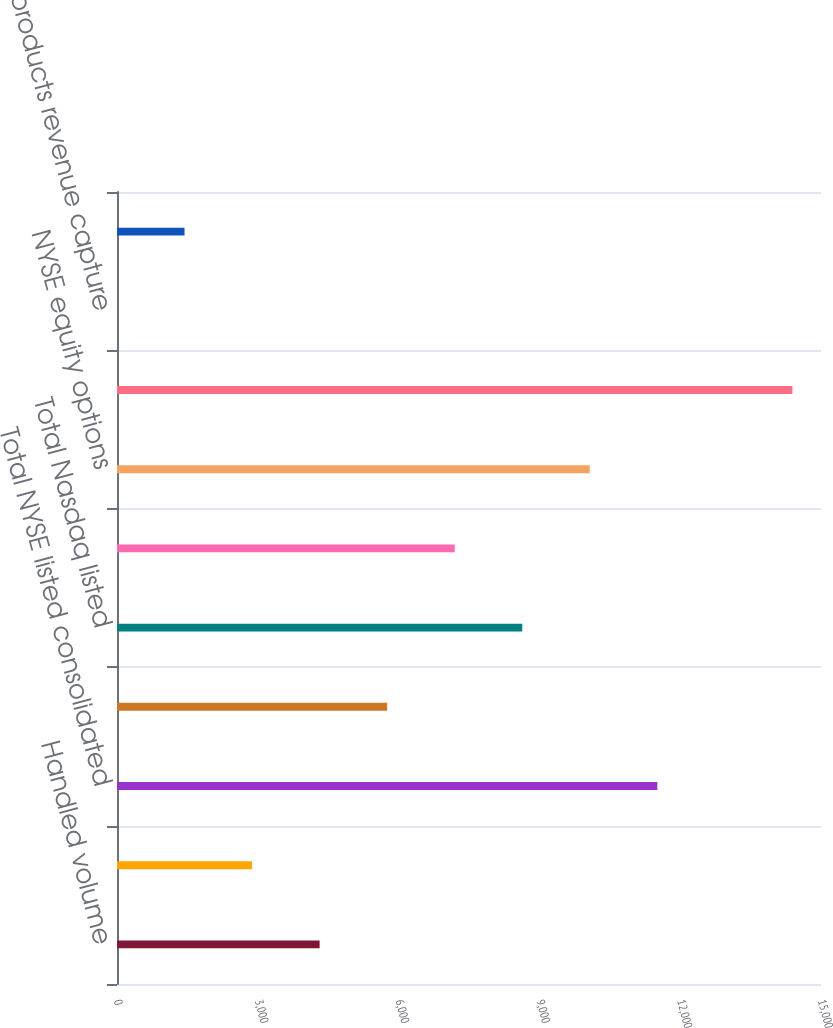<chart> <loc_0><loc_0><loc_500><loc_500><bar_chart><fcel>Handled volume<fcel>Matched volume<fcel>Total NYSE listed consolidated<fcel>Total NYSE Arca NYSE American<fcel>Total Nasdaq listed<fcel>Total cash volume handled<fcel>NYSE equity options<fcel>Total equity options volume<fcel>Cash products revenue capture<fcel>Equity options rate per<nl><fcel>4317.35<fcel>2878.25<fcel>11512.8<fcel>5756.45<fcel>8634.65<fcel>7195.55<fcel>10073.7<fcel>14391<fcel>0.05<fcel>1439.15<nl></chart> 